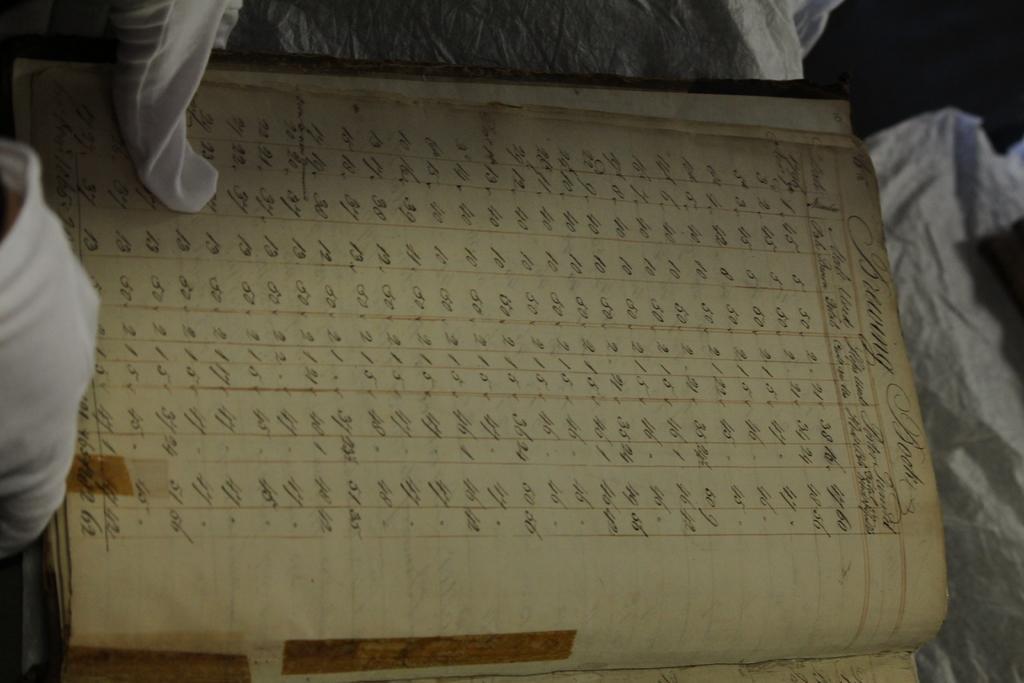Describe this image in one or two sentences. In the image I can see a register in which there is something written. 